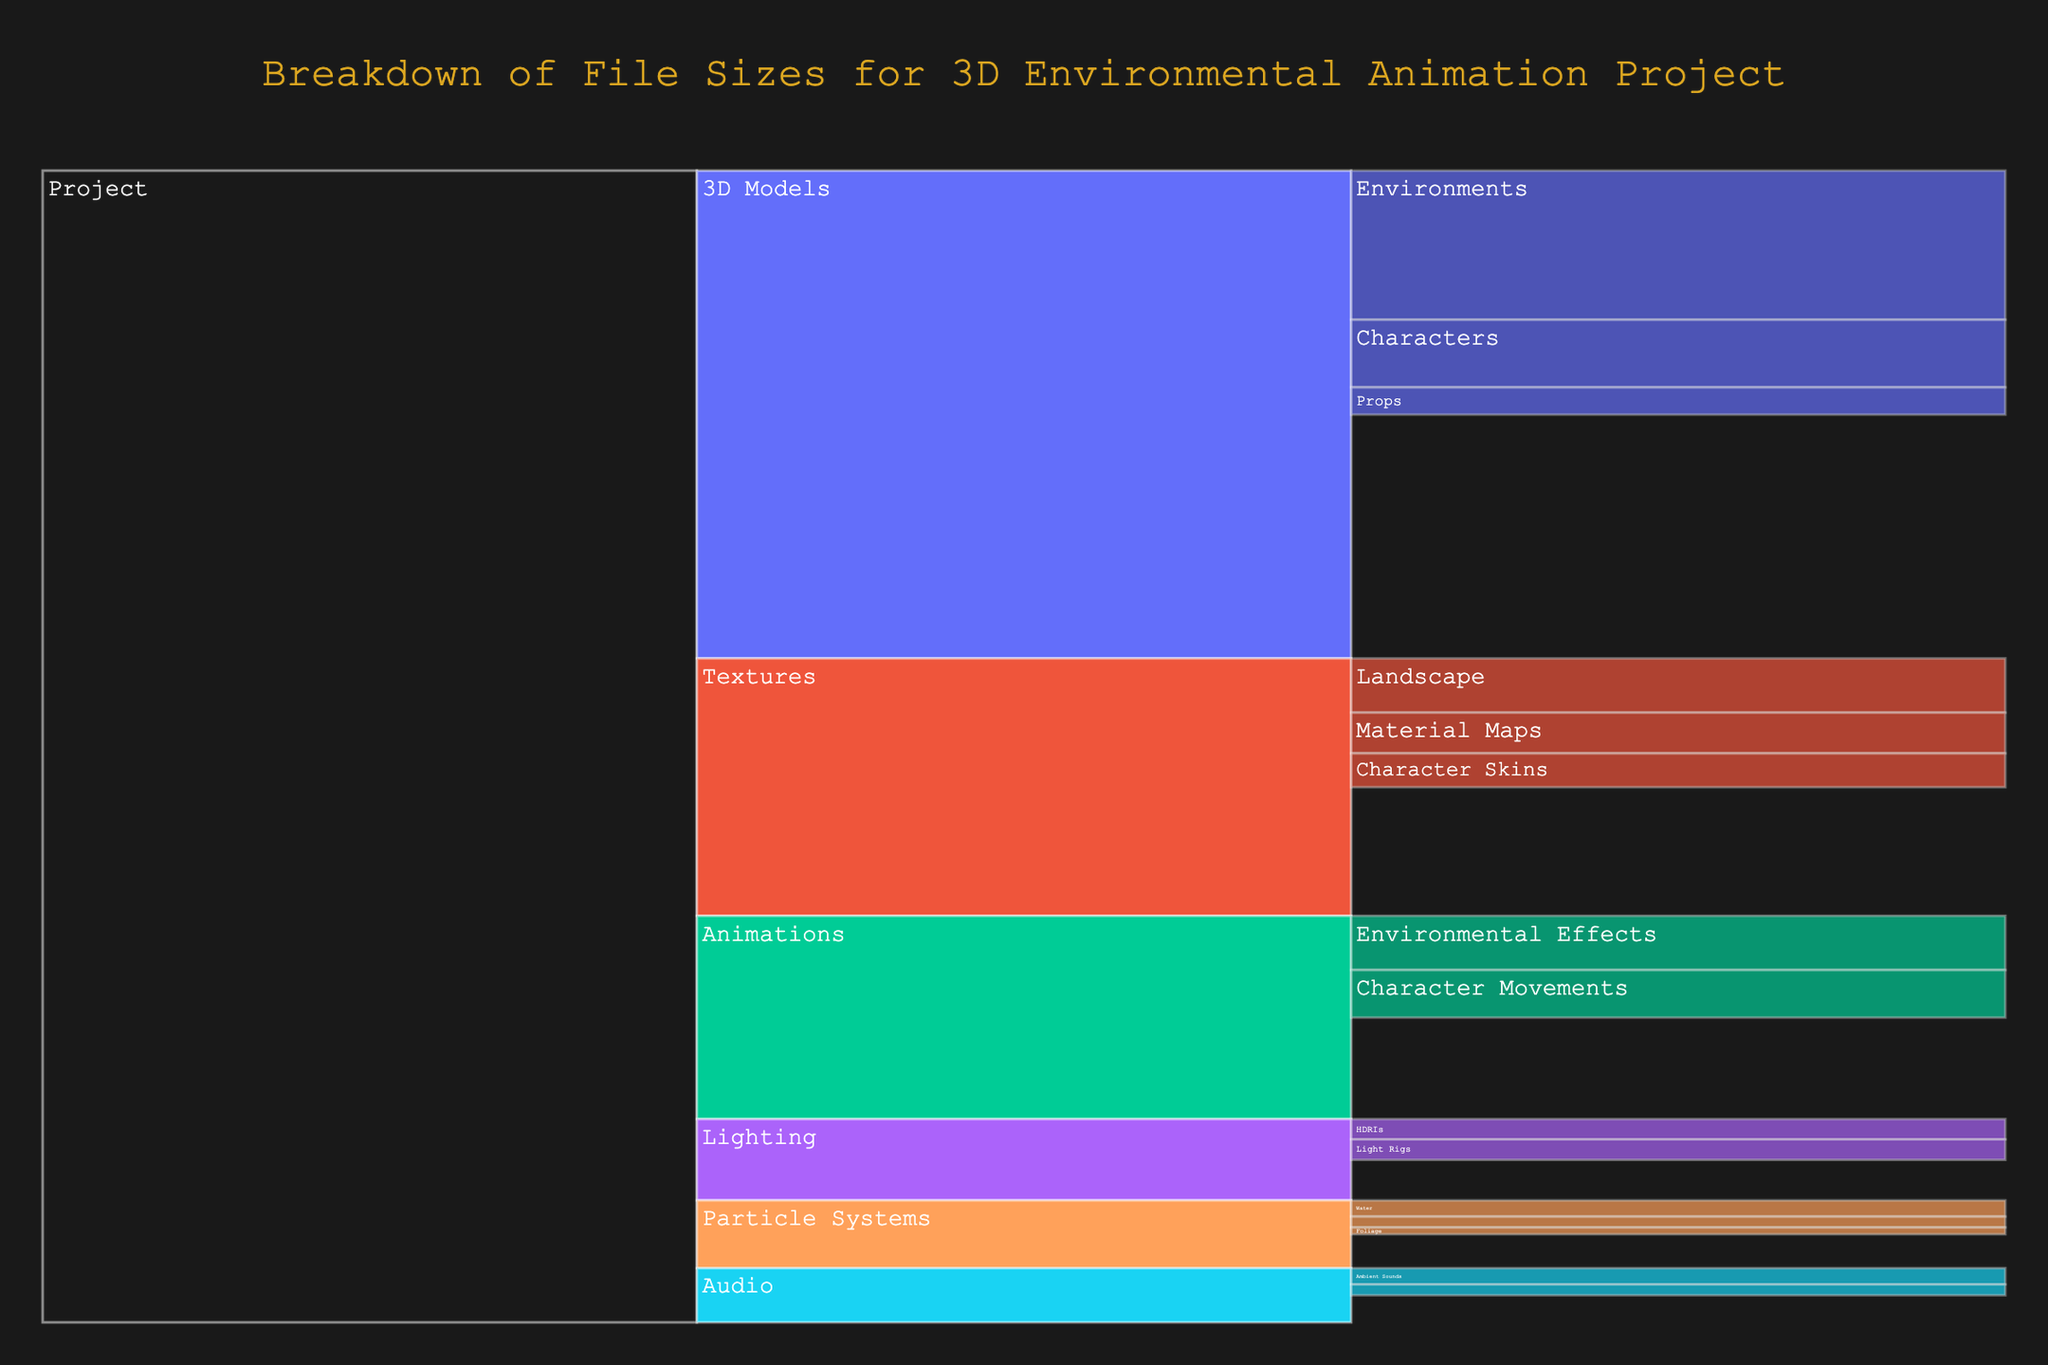What is the total file size for the 'Textures' category? To find this, locate the 'Textures' section in the icicle chart and look for its value.
Answer: 95 MB Which section has a larger file size, '3D Models' or 'Animations'? Compare the values for the '3D Models' section (180 MB) and the 'Animations' section (75 MB).
Answer: 3D Models What is the file size difference between 'HDRIs' and 'Light Rigs' in the 'Lighting' category? Identify the values for 'HDRIs' (15 MB) and 'Light Rigs' (15 MB), then subtract one from the other to find the difference.
Answer: 0 MB What is the combined file size of 'Dust', 'Water', and 'Foliage' in the 'Particle Systems'? Locate the 'Particle Systems' section and get the values for 'Dust' (8 MB), 'Water' (12 MB), and 'Foliage' (5 MB), then sum them up: 8 + 12 + 5.
Answer: 25 MB Which has a smaller file size, 'Character Movements' or 'Environmental Effects'? Compare the values for 'Character Movements' (35 MB) and 'Environmental Effects' (40 MB).
Answer: Character Movements What is the title of the chart? The title is prominently displayed at the top of the chart.
Answer: Breakdown of File Sizes for 3D Environmental Animation Project How many subcategories are there under the 'Audio' category? Go to the 'Audio' section and count the number of branches or leaves coming off it.
Answer: 2 What is the total file size for all categories under the 'Project'? Sum all the primary categories under 'Project': 180 (3D Models) + 95 (Textures) + 75 (Animations) + 30 (Lighting) + 25 (Particle Systems) + 20 (Audio). 180 + 95 + 75 + 30 + 25 + 20.
Answer: 425 MB What is the largest subcategory under '3D Models'? Look at the '3D Models' category and identify which subcategory has the highest value: 50 (Characters), 110 (Environments), 20 (Props).
Answer: Environments How does the size of 'Ambient Sounds' compare to 'Sound Effects' under the 'Audio' category? Compare the values for 'Ambient Sounds' (12 MB) and 'Sound Effects' (8 MB).
Answer: Ambient Sounds is larger 